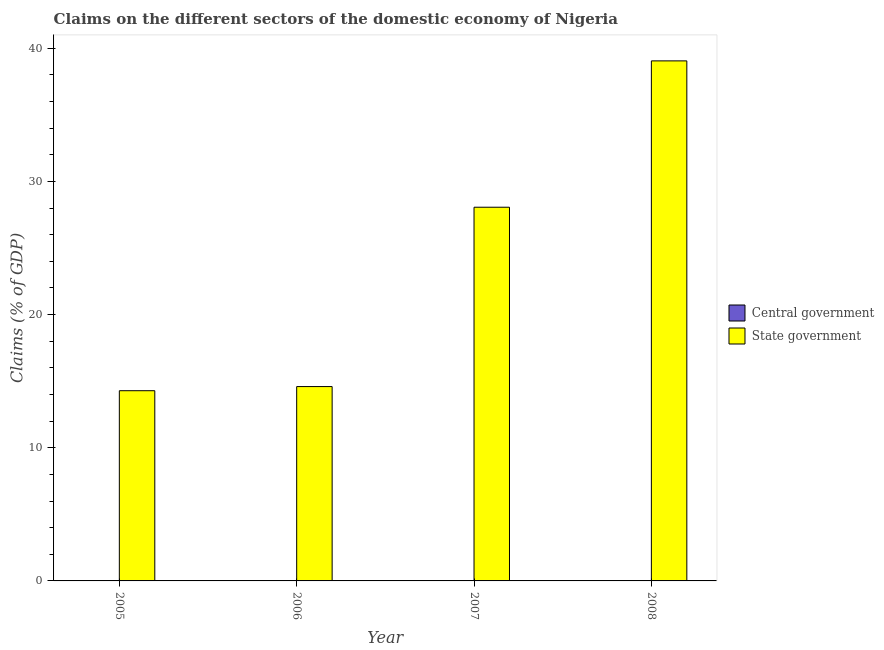How many different coloured bars are there?
Offer a terse response. 1. Are the number of bars per tick equal to the number of legend labels?
Ensure brevity in your answer.  No. Are the number of bars on each tick of the X-axis equal?
Provide a succinct answer. Yes. How many bars are there on the 3rd tick from the right?
Your response must be concise. 1. In how many cases, is the number of bars for a given year not equal to the number of legend labels?
Your answer should be compact. 4. What is the claims on state government in 2006?
Provide a succinct answer. 14.59. Across all years, what is the maximum claims on state government?
Keep it short and to the point. 39.05. Across all years, what is the minimum claims on central government?
Your answer should be compact. 0. In which year was the claims on state government maximum?
Provide a short and direct response. 2008. What is the difference between the claims on state government in 2006 and that in 2008?
Your answer should be compact. -24.46. What is the difference between the claims on central government in 2005 and the claims on state government in 2008?
Keep it short and to the point. 0. In how many years, is the claims on central government greater than 14 %?
Provide a succinct answer. 0. What is the ratio of the claims on state government in 2006 to that in 2008?
Keep it short and to the point. 0.37. Is the claims on state government in 2006 less than that in 2007?
Give a very brief answer. Yes. What is the difference between the highest and the second highest claims on state government?
Your answer should be very brief. 10.99. What is the difference between the highest and the lowest claims on state government?
Make the answer very short. 24.77. In how many years, is the claims on central government greater than the average claims on central government taken over all years?
Your answer should be compact. 0. How many bars are there?
Give a very brief answer. 4. Are all the bars in the graph horizontal?
Provide a succinct answer. No. Are the values on the major ticks of Y-axis written in scientific E-notation?
Keep it short and to the point. No. Does the graph contain any zero values?
Your answer should be compact. Yes. Does the graph contain grids?
Offer a very short reply. No. What is the title of the graph?
Provide a succinct answer. Claims on the different sectors of the domestic economy of Nigeria. Does "Non-resident workers" appear as one of the legend labels in the graph?
Offer a very short reply. No. What is the label or title of the Y-axis?
Ensure brevity in your answer.  Claims (% of GDP). What is the Claims (% of GDP) of State government in 2005?
Offer a terse response. 14.28. What is the Claims (% of GDP) of State government in 2006?
Make the answer very short. 14.59. What is the Claims (% of GDP) in State government in 2007?
Provide a short and direct response. 28.06. What is the Claims (% of GDP) in State government in 2008?
Offer a terse response. 39.05. Across all years, what is the maximum Claims (% of GDP) of State government?
Offer a very short reply. 39.05. Across all years, what is the minimum Claims (% of GDP) in State government?
Keep it short and to the point. 14.28. What is the total Claims (% of GDP) in State government in the graph?
Give a very brief answer. 95.99. What is the difference between the Claims (% of GDP) of State government in 2005 and that in 2006?
Keep it short and to the point. -0.31. What is the difference between the Claims (% of GDP) of State government in 2005 and that in 2007?
Offer a very short reply. -13.78. What is the difference between the Claims (% of GDP) of State government in 2005 and that in 2008?
Ensure brevity in your answer.  -24.77. What is the difference between the Claims (% of GDP) in State government in 2006 and that in 2007?
Ensure brevity in your answer.  -13.47. What is the difference between the Claims (% of GDP) in State government in 2006 and that in 2008?
Keep it short and to the point. -24.46. What is the difference between the Claims (% of GDP) of State government in 2007 and that in 2008?
Offer a terse response. -10.99. What is the average Claims (% of GDP) in State government per year?
Make the answer very short. 24. What is the ratio of the Claims (% of GDP) of State government in 2005 to that in 2006?
Offer a very short reply. 0.98. What is the ratio of the Claims (% of GDP) in State government in 2005 to that in 2007?
Provide a succinct answer. 0.51. What is the ratio of the Claims (% of GDP) in State government in 2005 to that in 2008?
Your response must be concise. 0.37. What is the ratio of the Claims (% of GDP) in State government in 2006 to that in 2007?
Your answer should be very brief. 0.52. What is the ratio of the Claims (% of GDP) of State government in 2006 to that in 2008?
Keep it short and to the point. 0.37. What is the ratio of the Claims (% of GDP) of State government in 2007 to that in 2008?
Give a very brief answer. 0.72. What is the difference between the highest and the second highest Claims (% of GDP) of State government?
Ensure brevity in your answer.  10.99. What is the difference between the highest and the lowest Claims (% of GDP) of State government?
Make the answer very short. 24.77. 